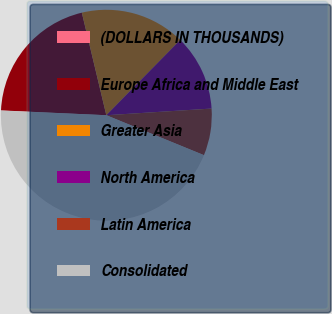Convert chart. <chart><loc_0><loc_0><loc_500><loc_500><pie_chart><fcel>(DOLLARS IN THOUSANDS)<fcel>Europe Africa and Middle East<fcel>Greater Asia<fcel>North America<fcel>Latin America<fcel>Consolidated<nl><fcel>0.03%<fcel>20.54%<fcel>16.09%<fcel>11.64%<fcel>7.19%<fcel>44.53%<nl></chart> 